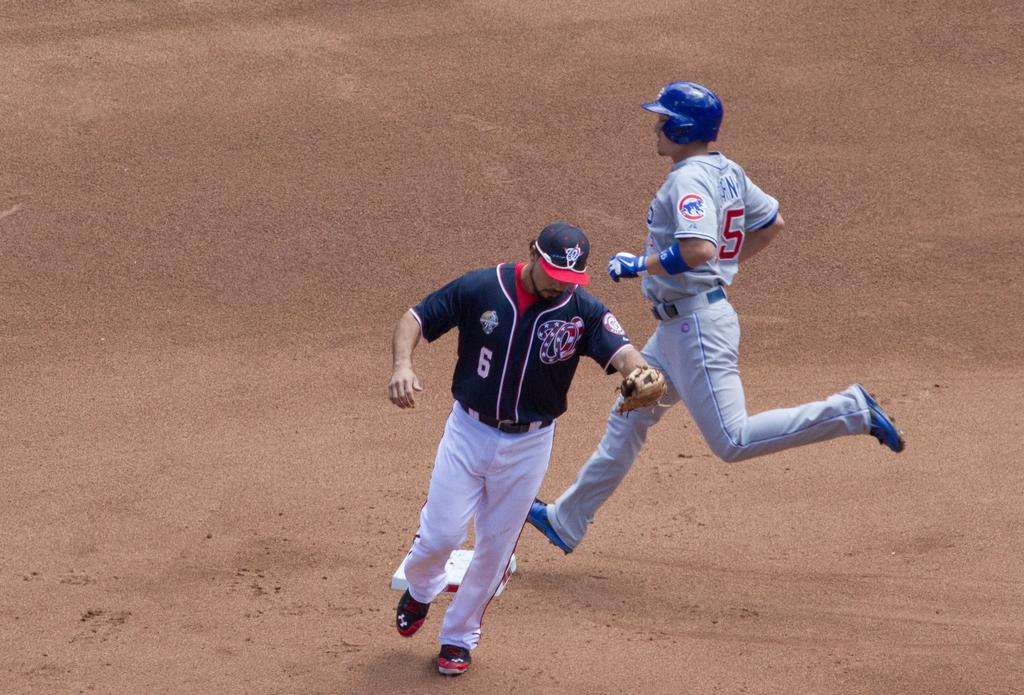<image>
Render a clear and concise summary of the photo. Player number 6 runs away from the base while player number 5 runs towards it 